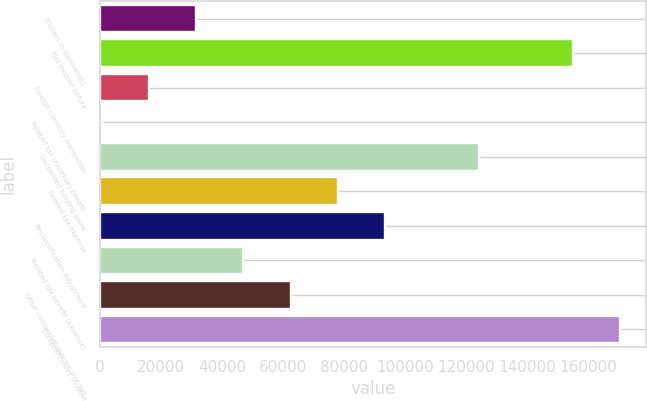<chart> <loc_0><loc_0><loc_500><loc_500><bar_chart><fcel>(Dollars in thousands)<fcel>Net income before<fcel>Foreign currency translation<fcel>Related tax (expense) benefit<fcel>Unrealized holding gains<fcel>Related tax expense<fcel>Reclassification adjustment<fcel>Related tax benefit (expense)<fcel>Other comprehensive income net<fcel>Comprehensive income<nl><fcel>31602.2<fcel>155055<fcel>16170.6<fcel>739<fcel>124192<fcel>77897<fcel>93328.6<fcel>47033.8<fcel>62465.4<fcel>170487<nl></chart> 